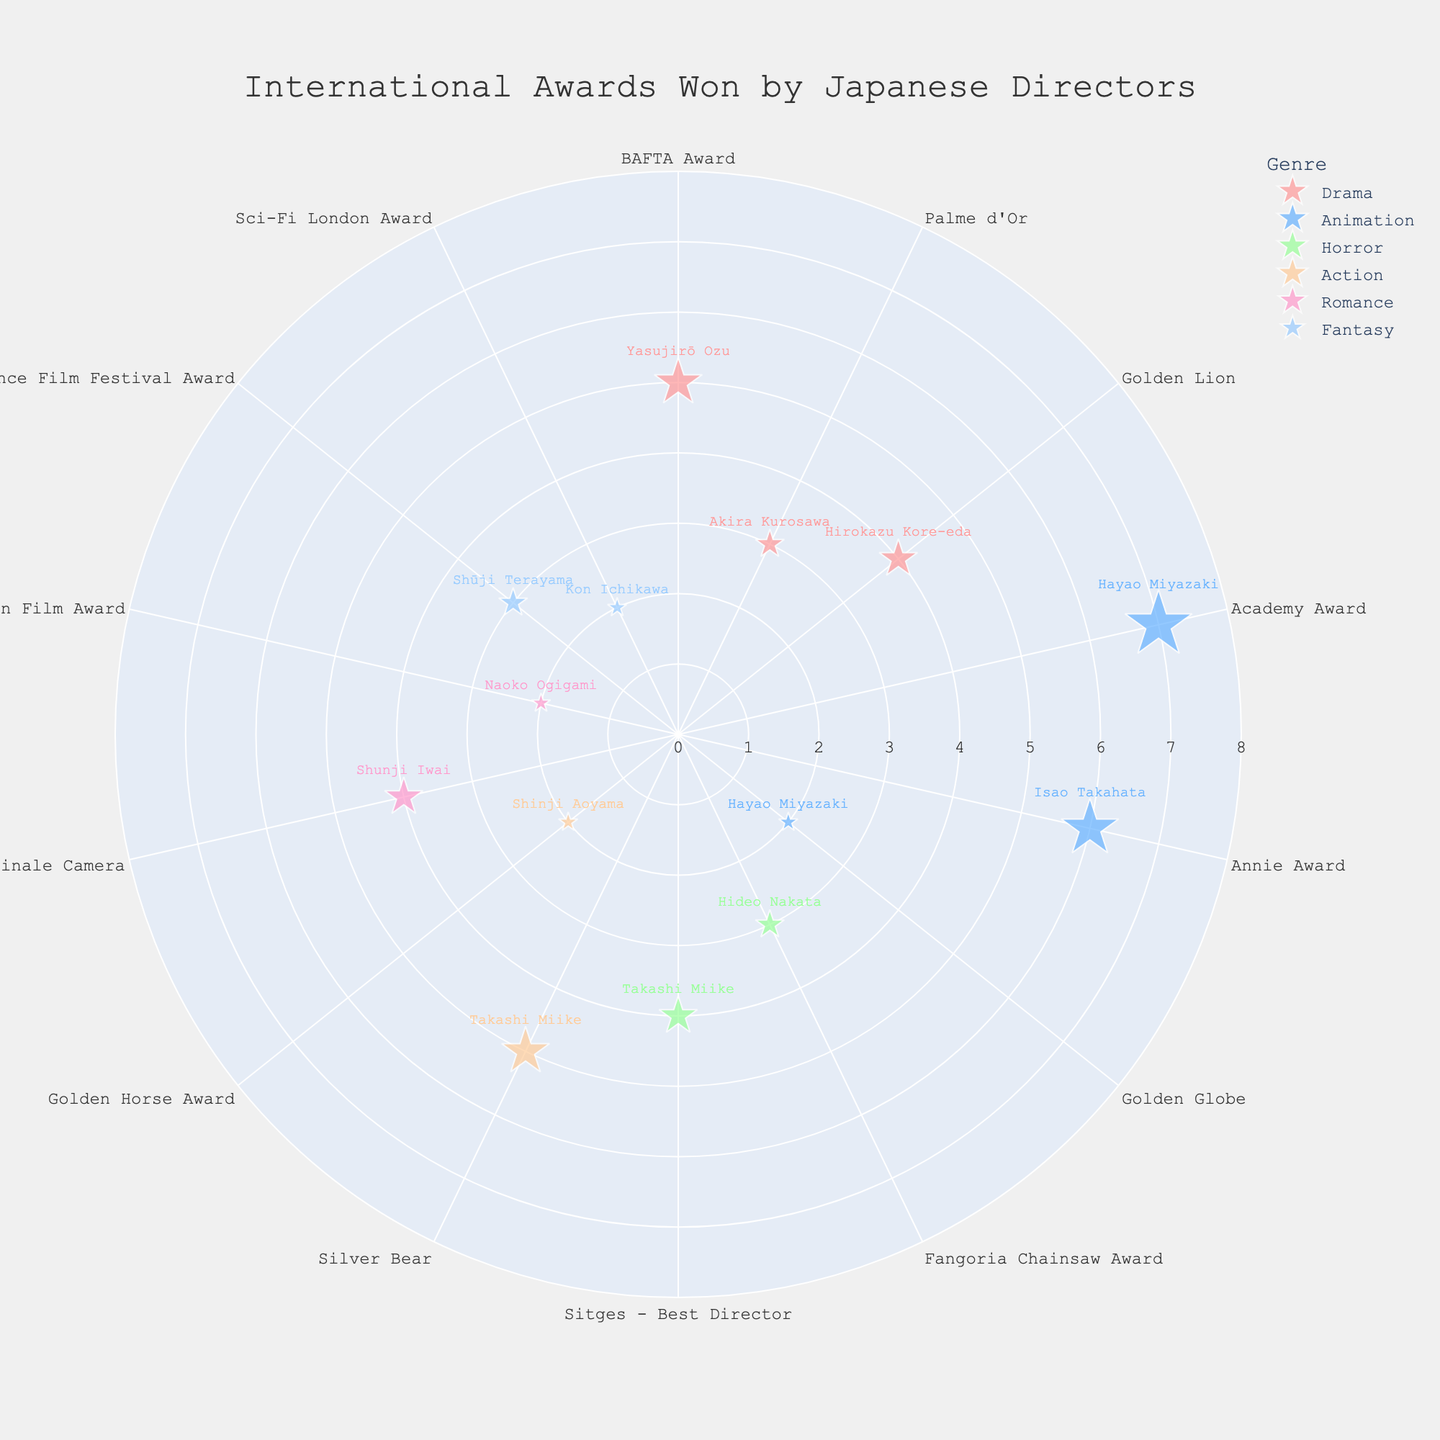What's the title of the figure? The title of the figure is prominently displayed at the top and typically provides a summary of what the figure represents.
Answer: International Awards Won by Japanese Directors Which genre's directors have won the highest number of awards? By observing the size of the markers, which are proportional to the number of awards, we can see that the largest markers are located in the 'Animation' category.
Answer: Animation Who is the director with the highest number of awards? The size of the markers and the text details the number of awards. By focusing on the largest marker, one sees that 'Hayao Miyazaki' in the 'Animation' genre has the largest marker for the Academy Award with 7 awards.
Answer: Hayao Miyazaki Which genre has the widest variety of awards categories? One must count the number of different award categories within each genre. The 'Animation' genre has Academy Award, Annie Award, and Golden Globe, totaling three. Other genres do not surpass this count in variety.
Answer: Animation What is the combined number of awards won by directors in the 'Drama' genre? Adding up the awards for each 'Drama' director: 5 (Ozu) + 3 (Kurosawa) + 4 (Kore-eda) = 12.
Answer: 12 Which award category has the most awards within the 'Horror' genre? Examine the markers within the 'Horror' genre and compare their sizes. 'Sitges - Best Director' has slightly larger markers (4) compared to 'Fangoria Chainsaw Award' (3).
Answer: Sitges - Best Director How many directors are recognized in the 'Romance' genre? Count the number of unique text labels (directors' names) under the 'Romance' genre's markers. 'Shunji Iwai' and 'Naoko Ogigami' are listed, yielding two directors.
Answer: 2 What is the average number of awards won by 'Action' genre directors? Sum the awards in the 'Action' genre, 5 (Miike) + 2 (Aoyama) = 7. Then divide by the number of directors, which is 2. 7 / 2 = 3.5.
Answer: 3.5 How does the number of awards won by Shunji Iwai in the 'Romance' genre compare to that of Shinji Aoyama in the 'Action' genre? By looking and comparing the sizes of the markers, Shunji Iwai has won 4 awards and Shinji Aoyama has won 2 awards. Therefore, Shunji Iwai has won more.
Answer: Shunji Iwai has more Which genre has the least number of directors represented? Count the number of unique text labels per genre. 'Fantasy' has 'Shūji Terayama' and 'Kon Ichikawa', totaling 2 directors, while other genres have more. Thus, 'Fantasy' and 'Action' genres are two with the least, but since Action has more awards, we go with Fantasy.
Answer: Fantasy 